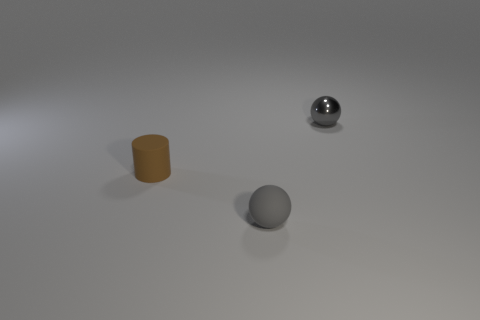What is the color of the small cylinder?
Make the answer very short. Brown. Is the color of the cylinder the same as the rubber ball?
Your answer should be compact. No. What number of gray metallic balls are in front of the gray sphere in front of the gray metal sphere?
Ensure brevity in your answer.  0. There is a object that is on the right side of the tiny brown object and behind the small gray rubber ball; what size is it?
Give a very brief answer. Small. What is the gray sphere that is in front of the small brown rubber object made of?
Keep it short and to the point. Rubber. Are there any small purple rubber objects of the same shape as the shiny thing?
Offer a very short reply. No. What number of other small rubber objects are the same shape as the brown thing?
Your answer should be very brief. 0. There is a gray object in front of the tiny metallic ball; does it have the same size as the gray thing that is behind the small matte sphere?
Keep it short and to the point. Yes. The small rubber object on the left side of the tiny rubber thing that is on the right side of the brown rubber cylinder is what shape?
Provide a short and direct response. Cylinder. Are there an equal number of tiny gray matte spheres that are in front of the tiny cylinder and small purple cubes?
Provide a short and direct response. No. 